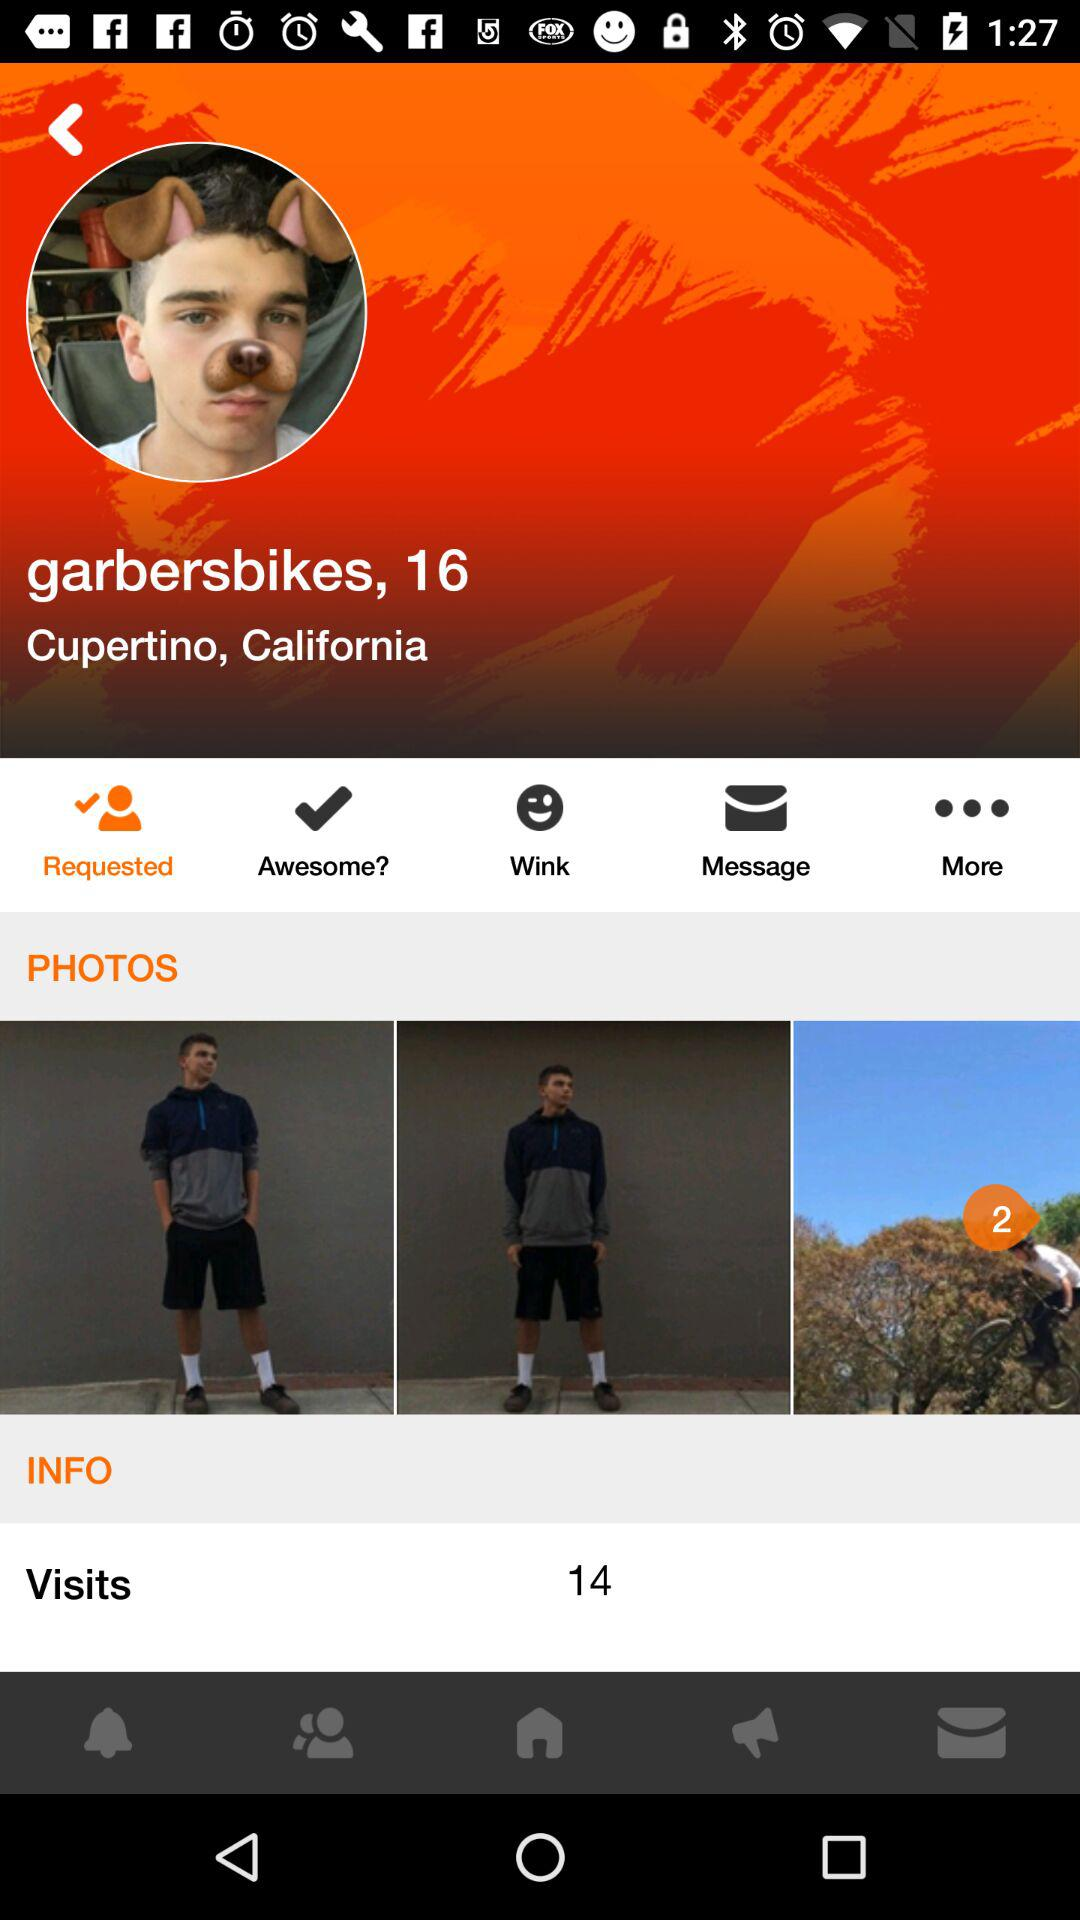Which option is selected? The selected option is "Requested". 